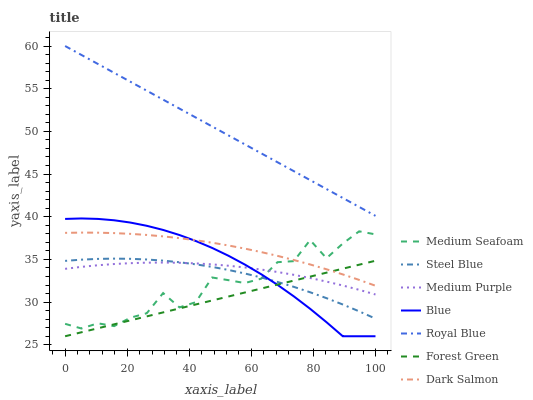Does Forest Green have the minimum area under the curve?
Answer yes or no. Yes. Does Royal Blue have the maximum area under the curve?
Answer yes or no. Yes. Does Steel Blue have the minimum area under the curve?
Answer yes or no. No. Does Steel Blue have the maximum area under the curve?
Answer yes or no. No. Is Forest Green the smoothest?
Answer yes or no. Yes. Is Medium Seafoam the roughest?
Answer yes or no. Yes. Is Steel Blue the smoothest?
Answer yes or no. No. Is Steel Blue the roughest?
Answer yes or no. No. Does Blue have the lowest value?
Answer yes or no. Yes. Does Steel Blue have the lowest value?
Answer yes or no. No. Does Royal Blue have the highest value?
Answer yes or no. Yes. Does Steel Blue have the highest value?
Answer yes or no. No. Is Forest Green less than Royal Blue?
Answer yes or no. Yes. Is Dark Salmon greater than Medium Purple?
Answer yes or no. Yes. Does Medium Seafoam intersect Dark Salmon?
Answer yes or no. Yes. Is Medium Seafoam less than Dark Salmon?
Answer yes or no. No. Is Medium Seafoam greater than Dark Salmon?
Answer yes or no. No. Does Forest Green intersect Royal Blue?
Answer yes or no. No. 